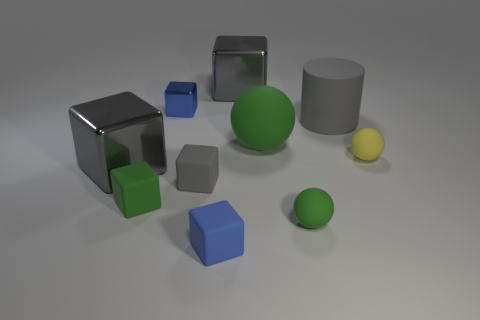What shape is the small rubber object that is the same color as the cylinder?
Offer a terse response. Cube. What number of cylinders are either gray shiny objects or yellow objects?
Your answer should be compact. 0. There is a large block that is in front of the ball that is behind the yellow matte thing; what color is it?
Your response must be concise. Gray. Is the color of the cylinder the same as the big shiny cube on the right side of the blue rubber thing?
Provide a short and direct response. Yes. There is a yellow ball that is the same material as the small green block; what size is it?
Provide a short and direct response. Small. What size is the cube that is the same color as the small shiny thing?
Provide a succinct answer. Small. Do the rubber cylinder and the small metallic cube have the same color?
Keep it short and to the point. No. Is there a small blue rubber object behind the gray matte object in front of the block that is on the left side of the small green rubber cube?
Your response must be concise. No. How many matte spheres have the same size as the blue metallic thing?
Give a very brief answer. 2. There is a gray rubber thing in front of the gray matte cylinder; does it have the same size as the gray metal object that is in front of the yellow object?
Your response must be concise. No. 